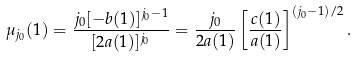Convert formula to latex. <formula><loc_0><loc_0><loc_500><loc_500>\mu _ { j _ { 0 } } ( 1 ) = \frac { j _ { 0 } [ - b ( 1 ) ] ^ { j _ { 0 } - 1 } } { [ 2 a ( 1 ) ] ^ { j _ { 0 } } } = \frac { j _ { 0 } } { 2 a ( 1 ) } \left [ \frac { c ( 1 ) } { a ( 1 ) } \right ] ^ { ( j _ { 0 } - 1 ) / 2 } .</formula> 